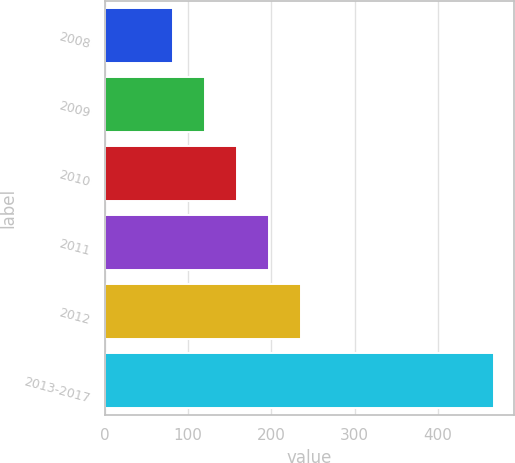Convert chart. <chart><loc_0><loc_0><loc_500><loc_500><bar_chart><fcel>2008<fcel>2009<fcel>2010<fcel>2011<fcel>2012<fcel>2013-2017<nl><fcel>82<fcel>120.55<fcel>159.1<fcel>197.65<fcel>236.2<fcel>467.5<nl></chart> 